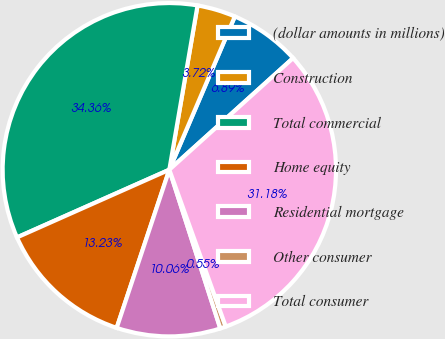<chart> <loc_0><loc_0><loc_500><loc_500><pie_chart><fcel>(dollar amounts in millions)<fcel>Construction<fcel>Total commercial<fcel>Home equity<fcel>Residential mortgage<fcel>Other consumer<fcel>Total consumer<nl><fcel>6.89%<fcel>3.72%<fcel>34.36%<fcel>13.23%<fcel>10.06%<fcel>0.55%<fcel>31.18%<nl></chart> 